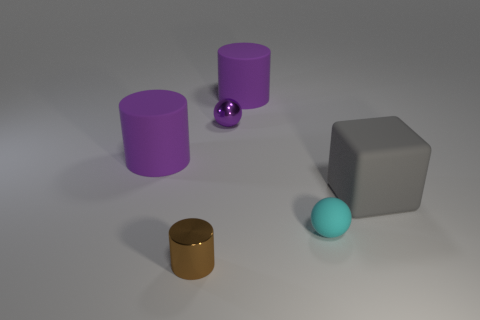What shape is the tiny shiny object that is on the right side of the brown metal thing?
Give a very brief answer. Sphere. The small thing to the right of the tiny purple thing that is behind the purple matte cylinder that is to the left of the brown metal thing is what shape?
Make the answer very short. Sphere. What number of objects are either cylinders or big gray rubber things?
Offer a very short reply. 4. There is a small metallic thing that is in front of the large gray rubber cube; does it have the same shape as the tiny metallic thing behind the big gray cube?
Your answer should be very brief. No. How many tiny shiny things are in front of the tiny purple shiny ball and behind the matte ball?
Your answer should be compact. 0. How many other objects are there of the same size as the cyan rubber sphere?
Provide a short and direct response. 2. What material is the object that is in front of the large gray rubber block and behind the small brown object?
Offer a terse response. Rubber. Is the color of the block the same as the big matte cylinder that is left of the purple ball?
Ensure brevity in your answer.  No. What size is the other object that is the same shape as the small cyan thing?
Keep it short and to the point. Small. There is a thing that is on the left side of the tiny purple metal sphere and behind the metallic cylinder; what is its shape?
Keep it short and to the point. Cylinder. 